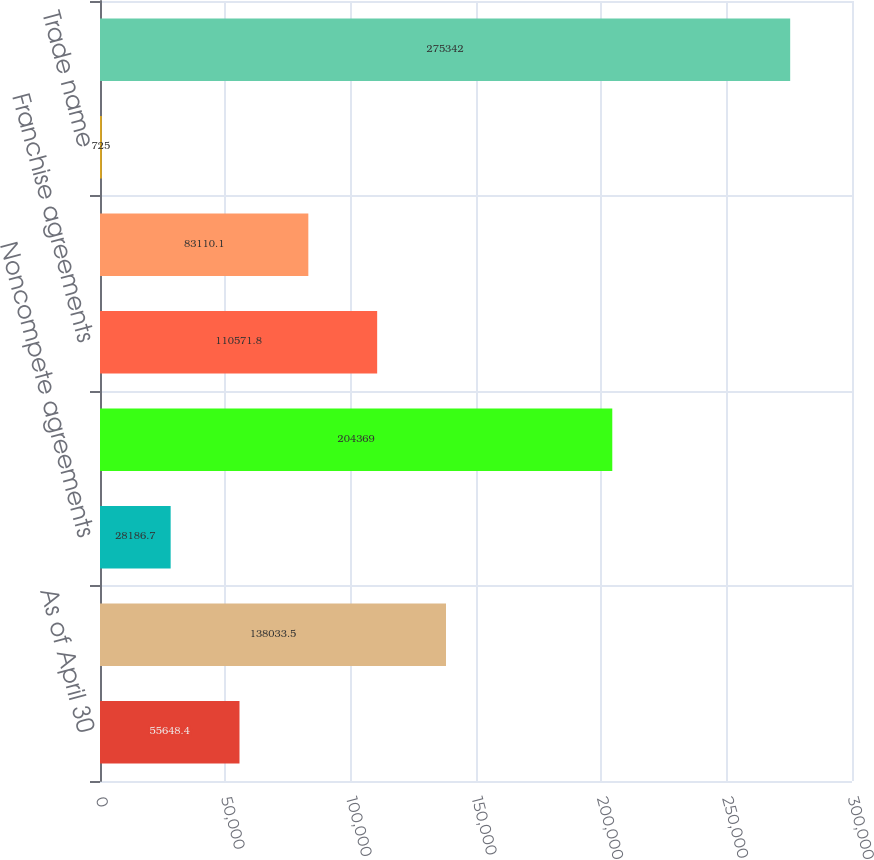Convert chart. <chart><loc_0><loc_0><loc_500><loc_500><bar_chart><fcel>As of April 30<fcel>Customer relationships<fcel>Noncompete agreements<fcel>Reacquired franchise rights<fcel>Franchise agreements<fcel>Purchased technology<fcel>Trade name<fcel>Total intangible assets<nl><fcel>55648.4<fcel>138034<fcel>28186.7<fcel>204369<fcel>110572<fcel>83110.1<fcel>725<fcel>275342<nl></chart> 